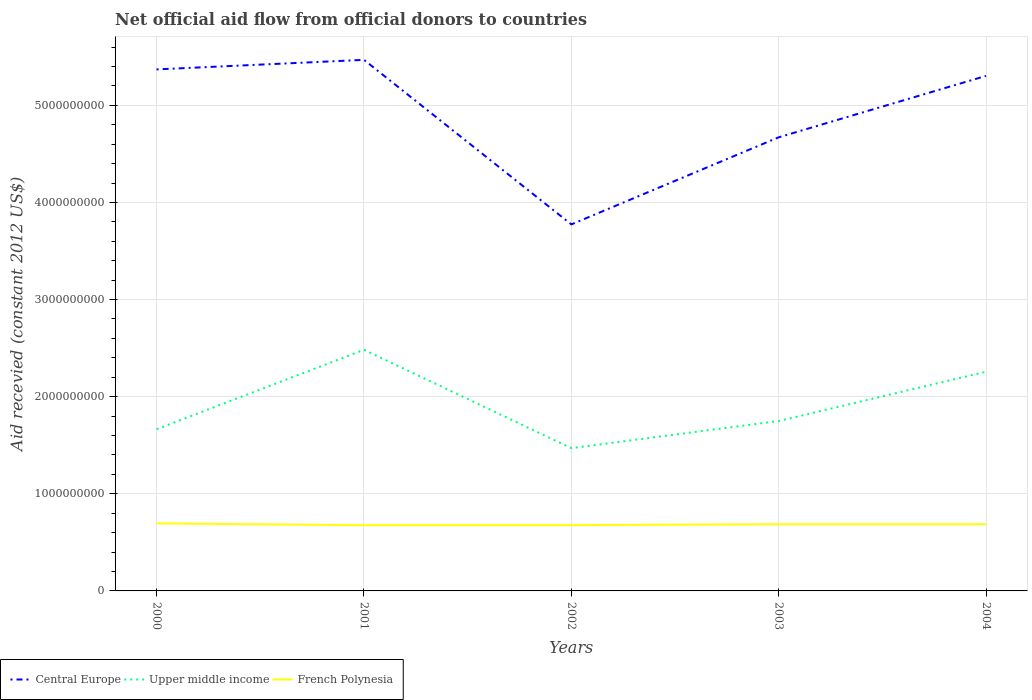Is the number of lines equal to the number of legend labels?
Offer a very short reply. Yes. Across all years, what is the maximum total aid received in French Polynesia?
Provide a succinct answer. 6.76e+08. In which year was the total aid received in Central Europe maximum?
Your answer should be compact. 2002. What is the total total aid received in Central Europe in the graph?
Your answer should be compact. 1.65e+08. What is the difference between the highest and the second highest total aid received in French Polynesia?
Offer a very short reply. 1.88e+07. Is the total aid received in Central Europe strictly greater than the total aid received in Upper middle income over the years?
Your answer should be compact. No. How many lines are there?
Your answer should be very brief. 3. How many legend labels are there?
Your answer should be very brief. 3. What is the title of the graph?
Offer a very short reply. Net official aid flow from official donors to countries. Does "Kiribati" appear as one of the legend labels in the graph?
Your answer should be very brief. No. What is the label or title of the Y-axis?
Offer a very short reply. Aid recevied (constant 2012 US$). What is the Aid recevied (constant 2012 US$) of Central Europe in 2000?
Keep it short and to the point. 5.37e+09. What is the Aid recevied (constant 2012 US$) in Upper middle income in 2000?
Your answer should be very brief. 1.67e+09. What is the Aid recevied (constant 2012 US$) in French Polynesia in 2000?
Your answer should be very brief. 6.95e+08. What is the Aid recevied (constant 2012 US$) in Central Europe in 2001?
Your answer should be compact. 5.47e+09. What is the Aid recevied (constant 2012 US$) in Upper middle income in 2001?
Provide a succinct answer. 2.48e+09. What is the Aid recevied (constant 2012 US$) of French Polynesia in 2001?
Provide a succinct answer. 6.76e+08. What is the Aid recevied (constant 2012 US$) of Central Europe in 2002?
Offer a terse response. 3.77e+09. What is the Aid recevied (constant 2012 US$) in Upper middle income in 2002?
Offer a terse response. 1.47e+09. What is the Aid recevied (constant 2012 US$) of French Polynesia in 2002?
Your answer should be compact. 6.78e+08. What is the Aid recevied (constant 2012 US$) in Central Europe in 2003?
Give a very brief answer. 4.67e+09. What is the Aid recevied (constant 2012 US$) in Upper middle income in 2003?
Your response must be concise. 1.75e+09. What is the Aid recevied (constant 2012 US$) in French Polynesia in 2003?
Provide a short and direct response. 6.87e+08. What is the Aid recevied (constant 2012 US$) in Central Europe in 2004?
Offer a terse response. 5.30e+09. What is the Aid recevied (constant 2012 US$) in Upper middle income in 2004?
Make the answer very short. 2.26e+09. What is the Aid recevied (constant 2012 US$) in French Polynesia in 2004?
Make the answer very short. 6.87e+08. Across all years, what is the maximum Aid recevied (constant 2012 US$) in Central Europe?
Your response must be concise. 5.47e+09. Across all years, what is the maximum Aid recevied (constant 2012 US$) of Upper middle income?
Provide a succinct answer. 2.48e+09. Across all years, what is the maximum Aid recevied (constant 2012 US$) in French Polynesia?
Ensure brevity in your answer.  6.95e+08. Across all years, what is the minimum Aid recevied (constant 2012 US$) of Central Europe?
Make the answer very short. 3.77e+09. Across all years, what is the minimum Aid recevied (constant 2012 US$) of Upper middle income?
Your response must be concise. 1.47e+09. Across all years, what is the minimum Aid recevied (constant 2012 US$) in French Polynesia?
Provide a succinct answer. 6.76e+08. What is the total Aid recevied (constant 2012 US$) of Central Europe in the graph?
Your answer should be very brief. 2.46e+1. What is the total Aid recevied (constant 2012 US$) of Upper middle income in the graph?
Provide a short and direct response. 9.62e+09. What is the total Aid recevied (constant 2012 US$) in French Polynesia in the graph?
Your answer should be compact. 3.42e+09. What is the difference between the Aid recevied (constant 2012 US$) in Central Europe in 2000 and that in 2001?
Offer a terse response. -9.83e+07. What is the difference between the Aid recevied (constant 2012 US$) in Upper middle income in 2000 and that in 2001?
Provide a short and direct response. -8.18e+08. What is the difference between the Aid recevied (constant 2012 US$) in French Polynesia in 2000 and that in 2001?
Make the answer very short. 1.88e+07. What is the difference between the Aid recevied (constant 2012 US$) of Central Europe in 2000 and that in 2002?
Provide a short and direct response. 1.60e+09. What is the difference between the Aid recevied (constant 2012 US$) in Upper middle income in 2000 and that in 2002?
Your answer should be very brief. 1.95e+08. What is the difference between the Aid recevied (constant 2012 US$) in French Polynesia in 2000 and that in 2002?
Ensure brevity in your answer.  1.77e+07. What is the difference between the Aid recevied (constant 2012 US$) of Central Europe in 2000 and that in 2003?
Offer a terse response. 6.99e+08. What is the difference between the Aid recevied (constant 2012 US$) in Upper middle income in 2000 and that in 2003?
Offer a terse response. -8.44e+07. What is the difference between the Aid recevied (constant 2012 US$) in French Polynesia in 2000 and that in 2003?
Your answer should be very brief. 8.64e+06. What is the difference between the Aid recevied (constant 2012 US$) in Central Europe in 2000 and that in 2004?
Provide a succinct answer. 6.68e+07. What is the difference between the Aid recevied (constant 2012 US$) in Upper middle income in 2000 and that in 2004?
Ensure brevity in your answer.  -5.92e+08. What is the difference between the Aid recevied (constant 2012 US$) of French Polynesia in 2000 and that in 2004?
Ensure brevity in your answer.  8.54e+06. What is the difference between the Aid recevied (constant 2012 US$) in Central Europe in 2001 and that in 2002?
Your answer should be very brief. 1.69e+09. What is the difference between the Aid recevied (constant 2012 US$) of Upper middle income in 2001 and that in 2002?
Provide a short and direct response. 1.01e+09. What is the difference between the Aid recevied (constant 2012 US$) in French Polynesia in 2001 and that in 2002?
Offer a terse response. -1.13e+06. What is the difference between the Aid recevied (constant 2012 US$) of Central Europe in 2001 and that in 2003?
Give a very brief answer. 7.98e+08. What is the difference between the Aid recevied (constant 2012 US$) of Upper middle income in 2001 and that in 2003?
Your answer should be very brief. 7.33e+08. What is the difference between the Aid recevied (constant 2012 US$) in French Polynesia in 2001 and that in 2003?
Provide a short and direct response. -1.02e+07. What is the difference between the Aid recevied (constant 2012 US$) in Central Europe in 2001 and that in 2004?
Keep it short and to the point. 1.65e+08. What is the difference between the Aid recevied (constant 2012 US$) of Upper middle income in 2001 and that in 2004?
Make the answer very short. 2.26e+08. What is the difference between the Aid recevied (constant 2012 US$) of French Polynesia in 2001 and that in 2004?
Your answer should be compact. -1.03e+07. What is the difference between the Aid recevied (constant 2012 US$) in Central Europe in 2002 and that in 2003?
Your answer should be very brief. -8.97e+08. What is the difference between the Aid recevied (constant 2012 US$) of Upper middle income in 2002 and that in 2003?
Give a very brief answer. -2.79e+08. What is the difference between the Aid recevied (constant 2012 US$) of French Polynesia in 2002 and that in 2003?
Offer a very short reply. -9.07e+06. What is the difference between the Aid recevied (constant 2012 US$) of Central Europe in 2002 and that in 2004?
Give a very brief answer. -1.53e+09. What is the difference between the Aid recevied (constant 2012 US$) in Upper middle income in 2002 and that in 2004?
Provide a short and direct response. -7.87e+08. What is the difference between the Aid recevied (constant 2012 US$) of French Polynesia in 2002 and that in 2004?
Keep it short and to the point. -9.17e+06. What is the difference between the Aid recevied (constant 2012 US$) in Central Europe in 2003 and that in 2004?
Your answer should be very brief. -6.32e+08. What is the difference between the Aid recevied (constant 2012 US$) of Upper middle income in 2003 and that in 2004?
Offer a very short reply. -5.07e+08. What is the difference between the Aid recevied (constant 2012 US$) in French Polynesia in 2003 and that in 2004?
Make the answer very short. -1.00e+05. What is the difference between the Aid recevied (constant 2012 US$) of Central Europe in 2000 and the Aid recevied (constant 2012 US$) of Upper middle income in 2001?
Keep it short and to the point. 2.89e+09. What is the difference between the Aid recevied (constant 2012 US$) in Central Europe in 2000 and the Aid recevied (constant 2012 US$) in French Polynesia in 2001?
Your answer should be compact. 4.69e+09. What is the difference between the Aid recevied (constant 2012 US$) of Upper middle income in 2000 and the Aid recevied (constant 2012 US$) of French Polynesia in 2001?
Offer a very short reply. 9.89e+08. What is the difference between the Aid recevied (constant 2012 US$) in Central Europe in 2000 and the Aid recevied (constant 2012 US$) in Upper middle income in 2002?
Give a very brief answer. 3.90e+09. What is the difference between the Aid recevied (constant 2012 US$) of Central Europe in 2000 and the Aid recevied (constant 2012 US$) of French Polynesia in 2002?
Your answer should be very brief. 4.69e+09. What is the difference between the Aid recevied (constant 2012 US$) in Upper middle income in 2000 and the Aid recevied (constant 2012 US$) in French Polynesia in 2002?
Your answer should be very brief. 9.88e+08. What is the difference between the Aid recevied (constant 2012 US$) of Central Europe in 2000 and the Aid recevied (constant 2012 US$) of Upper middle income in 2003?
Make the answer very short. 3.62e+09. What is the difference between the Aid recevied (constant 2012 US$) in Central Europe in 2000 and the Aid recevied (constant 2012 US$) in French Polynesia in 2003?
Your answer should be compact. 4.68e+09. What is the difference between the Aid recevied (constant 2012 US$) of Upper middle income in 2000 and the Aid recevied (constant 2012 US$) of French Polynesia in 2003?
Provide a short and direct response. 9.79e+08. What is the difference between the Aid recevied (constant 2012 US$) in Central Europe in 2000 and the Aid recevied (constant 2012 US$) in Upper middle income in 2004?
Your answer should be compact. 3.11e+09. What is the difference between the Aid recevied (constant 2012 US$) of Central Europe in 2000 and the Aid recevied (constant 2012 US$) of French Polynesia in 2004?
Your answer should be compact. 4.68e+09. What is the difference between the Aid recevied (constant 2012 US$) in Upper middle income in 2000 and the Aid recevied (constant 2012 US$) in French Polynesia in 2004?
Your answer should be compact. 9.78e+08. What is the difference between the Aid recevied (constant 2012 US$) in Central Europe in 2001 and the Aid recevied (constant 2012 US$) in Upper middle income in 2002?
Your response must be concise. 4.00e+09. What is the difference between the Aid recevied (constant 2012 US$) of Central Europe in 2001 and the Aid recevied (constant 2012 US$) of French Polynesia in 2002?
Your answer should be very brief. 4.79e+09. What is the difference between the Aid recevied (constant 2012 US$) of Upper middle income in 2001 and the Aid recevied (constant 2012 US$) of French Polynesia in 2002?
Your answer should be very brief. 1.81e+09. What is the difference between the Aid recevied (constant 2012 US$) of Central Europe in 2001 and the Aid recevied (constant 2012 US$) of Upper middle income in 2003?
Ensure brevity in your answer.  3.72e+09. What is the difference between the Aid recevied (constant 2012 US$) of Central Europe in 2001 and the Aid recevied (constant 2012 US$) of French Polynesia in 2003?
Provide a short and direct response. 4.78e+09. What is the difference between the Aid recevied (constant 2012 US$) in Upper middle income in 2001 and the Aid recevied (constant 2012 US$) in French Polynesia in 2003?
Your answer should be compact. 1.80e+09. What is the difference between the Aid recevied (constant 2012 US$) in Central Europe in 2001 and the Aid recevied (constant 2012 US$) in Upper middle income in 2004?
Provide a succinct answer. 3.21e+09. What is the difference between the Aid recevied (constant 2012 US$) in Central Europe in 2001 and the Aid recevied (constant 2012 US$) in French Polynesia in 2004?
Your answer should be compact. 4.78e+09. What is the difference between the Aid recevied (constant 2012 US$) in Upper middle income in 2001 and the Aid recevied (constant 2012 US$) in French Polynesia in 2004?
Give a very brief answer. 1.80e+09. What is the difference between the Aid recevied (constant 2012 US$) in Central Europe in 2002 and the Aid recevied (constant 2012 US$) in Upper middle income in 2003?
Give a very brief answer. 2.02e+09. What is the difference between the Aid recevied (constant 2012 US$) in Central Europe in 2002 and the Aid recevied (constant 2012 US$) in French Polynesia in 2003?
Ensure brevity in your answer.  3.09e+09. What is the difference between the Aid recevied (constant 2012 US$) in Upper middle income in 2002 and the Aid recevied (constant 2012 US$) in French Polynesia in 2003?
Offer a very short reply. 7.83e+08. What is the difference between the Aid recevied (constant 2012 US$) of Central Europe in 2002 and the Aid recevied (constant 2012 US$) of Upper middle income in 2004?
Your response must be concise. 1.52e+09. What is the difference between the Aid recevied (constant 2012 US$) in Central Europe in 2002 and the Aid recevied (constant 2012 US$) in French Polynesia in 2004?
Give a very brief answer. 3.09e+09. What is the difference between the Aid recevied (constant 2012 US$) in Upper middle income in 2002 and the Aid recevied (constant 2012 US$) in French Polynesia in 2004?
Offer a very short reply. 7.83e+08. What is the difference between the Aid recevied (constant 2012 US$) in Central Europe in 2003 and the Aid recevied (constant 2012 US$) in Upper middle income in 2004?
Ensure brevity in your answer.  2.41e+09. What is the difference between the Aid recevied (constant 2012 US$) of Central Europe in 2003 and the Aid recevied (constant 2012 US$) of French Polynesia in 2004?
Keep it short and to the point. 3.98e+09. What is the difference between the Aid recevied (constant 2012 US$) in Upper middle income in 2003 and the Aid recevied (constant 2012 US$) in French Polynesia in 2004?
Ensure brevity in your answer.  1.06e+09. What is the average Aid recevied (constant 2012 US$) of Central Europe per year?
Your response must be concise. 4.92e+09. What is the average Aid recevied (constant 2012 US$) of Upper middle income per year?
Provide a succinct answer. 1.92e+09. What is the average Aid recevied (constant 2012 US$) of French Polynesia per year?
Your answer should be very brief. 6.85e+08. In the year 2000, what is the difference between the Aid recevied (constant 2012 US$) in Central Europe and Aid recevied (constant 2012 US$) in Upper middle income?
Provide a succinct answer. 3.70e+09. In the year 2000, what is the difference between the Aid recevied (constant 2012 US$) of Central Europe and Aid recevied (constant 2012 US$) of French Polynesia?
Provide a succinct answer. 4.67e+09. In the year 2000, what is the difference between the Aid recevied (constant 2012 US$) of Upper middle income and Aid recevied (constant 2012 US$) of French Polynesia?
Offer a terse response. 9.70e+08. In the year 2001, what is the difference between the Aid recevied (constant 2012 US$) of Central Europe and Aid recevied (constant 2012 US$) of Upper middle income?
Offer a very short reply. 2.99e+09. In the year 2001, what is the difference between the Aid recevied (constant 2012 US$) of Central Europe and Aid recevied (constant 2012 US$) of French Polynesia?
Keep it short and to the point. 4.79e+09. In the year 2001, what is the difference between the Aid recevied (constant 2012 US$) in Upper middle income and Aid recevied (constant 2012 US$) in French Polynesia?
Your answer should be very brief. 1.81e+09. In the year 2002, what is the difference between the Aid recevied (constant 2012 US$) in Central Europe and Aid recevied (constant 2012 US$) in Upper middle income?
Provide a short and direct response. 2.30e+09. In the year 2002, what is the difference between the Aid recevied (constant 2012 US$) of Central Europe and Aid recevied (constant 2012 US$) of French Polynesia?
Your answer should be compact. 3.10e+09. In the year 2002, what is the difference between the Aid recevied (constant 2012 US$) in Upper middle income and Aid recevied (constant 2012 US$) in French Polynesia?
Your answer should be compact. 7.93e+08. In the year 2003, what is the difference between the Aid recevied (constant 2012 US$) in Central Europe and Aid recevied (constant 2012 US$) in Upper middle income?
Offer a terse response. 2.92e+09. In the year 2003, what is the difference between the Aid recevied (constant 2012 US$) in Central Europe and Aid recevied (constant 2012 US$) in French Polynesia?
Give a very brief answer. 3.98e+09. In the year 2003, what is the difference between the Aid recevied (constant 2012 US$) of Upper middle income and Aid recevied (constant 2012 US$) of French Polynesia?
Your answer should be compact. 1.06e+09. In the year 2004, what is the difference between the Aid recevied (constant 2012 US$) of Central Europe and Aid recevied (constant 2012 US$) of Upper middle income?
Provide a succinct answer. 3.05e+09. In the year 2004, what is the difference between the Aid recevied (constant 2012 US$) of Central Europe and Aid recevied (constant 2012 US$) of French Polynesia?
Ensure brevity in your answer.  4.62e+09. In the year 2004, what is the difference between the Aid recevied (constant 2012 US$) in Upper middle income and Aid recevied (constant 2012 US$) in French Polynesia?
Ensure brevity in your answer.  1.57e+09. What is the ratio of the Aid recevied (constant 2012 US$) in Central Europe in 2000 to that in 2001?
Make the answer very short. 0.98. What is the ratio of the Aid recevied (constant 2012 US$) in Upper middle income in 2000 to that in 2001?
Your answer should be very brief. 0.67. What is the ratio of the Aid recevied (constant 2012 US$) in French Polynesia in 2000 to that in 2001?
Make the answer very short. 1.03. What is the ratio of the Aid recevied (constant 2012 US$) of Central Europe in 2000 to that in 2002?
Your answer should be very brief. 1.42. What is the ratio of the Aid recevied (constant 2012 US$) of Upper middle income in 2000 to that in 2002?
Give a very brief answer. 1.13. What is the ratio of the Aid recevied (constant 2012 US$) of French Polynesia in 2000 to that in 2002?
Make the answer very short. 1.03. What is the ratio of the Aid recevied (constant 2012 US$) of Central Europe in 2000 to that in 2003?
Your answer should be compact. 1.15. What is the ratio of the Aid recevied (constant 2012 US$) in Upper middle income in 2000 to that in 2003?
Provide a succinct answer. 0.95. What is the ratio of the Aid recevied (constant 2012 US$) in French Polynesia in 2000 to that in 2003?
Your answer should be compact. 1.01. What is the ratio of the Aid recevied (constant 2012 US$) in Central Europe in 2000 to that in 2004?
Keep it short and to the point. 1.01. What is the ratio of the Aid recevied (constant 2012 US$) of Upper middle income in 2000 to that in 2004?
Offer a very short reply. 0.74. What is the ratio of the Aid recevied (constant 2012 US$) in French Polynesia in 2000 to that in 2004?
Ensure brevity in your answer.  1.01. What is the ratio of the Aid recevied (constant 2012 US$) in Central Europe in 2001 to that in 2002?
Keep it short and to the point. 1.45. What is the ratio of the Aid recevied (constant 2012 US$) in Upper middle income in 2001 to that in 2002?
Offer a very short reply. 1.69. What is the ratio of the Aid recevied (constant 2012 US$) of French Polynesia in 2001 to that in 2002?
Your answer should be compact. 1. What is the ratio of the Aid recevied (constant 2012 US$) of Central Europe in 2001 to that in 2003?
Give a very brief answer. 1.17. What is the ratio of the Aid recevied (constant 2012 US$) of Upper middle income in 2001 to that in 2003?
Keep it short and to the point. 1.42. What is the ratio of the Aid recevied (constant 2012 US$) of French Polynesia in 2001 to that in 2003?
Keep it short and to the point. 0.99. What is the ratio of the Aid recevied (constant 2012 US$) in Central Europe in 2001 to that in 2004?
Make the answer very short. 1.03. What is the ratio of the Aid recevied (constant 2012 US$) of Upper middle income in 2001 to that in 2004?
Ensure brevity in your answer.  1.1. What is the ratio of the Aid recevied (constant 2012 US$) of French Polynesia in 2001 to that in 2004?
Ensure brevity in your answer.  0.98. What is the ratio of the Aid recevied (constant 2012 US$) in Central Europe in 2002 to that in 2003?
Keep it short and to the point. 0.81. What is the ratio of the Aid recevied (constant 2012 US$) of Upper middle income in 2002 to that in 2003?
Make the answer very short. 0.84. What is the ratio of the Aid recevied (constant 2012 US$) of French Polynesia in 2002 to that in 2003?
Your answer should be very brief. 0.99. What is the ratio of the Aid recevied (constant 2012 US$) in Central Europe in 2002 to that in 2004?
Provide a short and direct response. 0.71. What is the ratio of the Aid recevied (constant 2012 US$) of Upper middle income in 2002 to that in 2004?
Your answer should be compact. 0.65. What is the ratio of the Aid recevied (constant 2012 US$) in French Polynesia in 2002 to that in 2004?
Ensure brevity in your answer.  0.99. What is the ratio of the Aid recevied (constant 2012 US$) of Central Europe in 2003 to that in 2004?
Your answer should be very brief. 0.88. What is the ratio of the Aid recevied (constant 2012 US$) in Upper middle income in 2003 to that in 2004?
Provide a short and direct response. 0.78. What is the difference between the highest and the second highest Aid recevied (constant 2012 US$) of Central Europe?
Offer a very short reply. 9.83e+07. What is the difference between the highest and the second highest Aid recevied (constant 2012 US$) in Upper middle income?
Keep it short and to the point. 2.26e+08. What is the difference between the highest and the second highest Aid recevied (constant 2012 US$) in French Polynesia?
Provide a succinct answer. 8.54e+06. What is the difference between the highest and the lowest Aid recevied (constant 2012 US$) in Central Europe?
Your response must be concise. 1.69e+09. What is the difference between the highest and the lowest Aid recevied (constant 2012 US$) in Upper middle income?
Ensure brevity in your answer.  1.01e+09. What is the difference between the highest and the lowest Aid recevied (constant 2012 US$) in French Polynesia?
Give a very brief answer. 1.88e+07. 